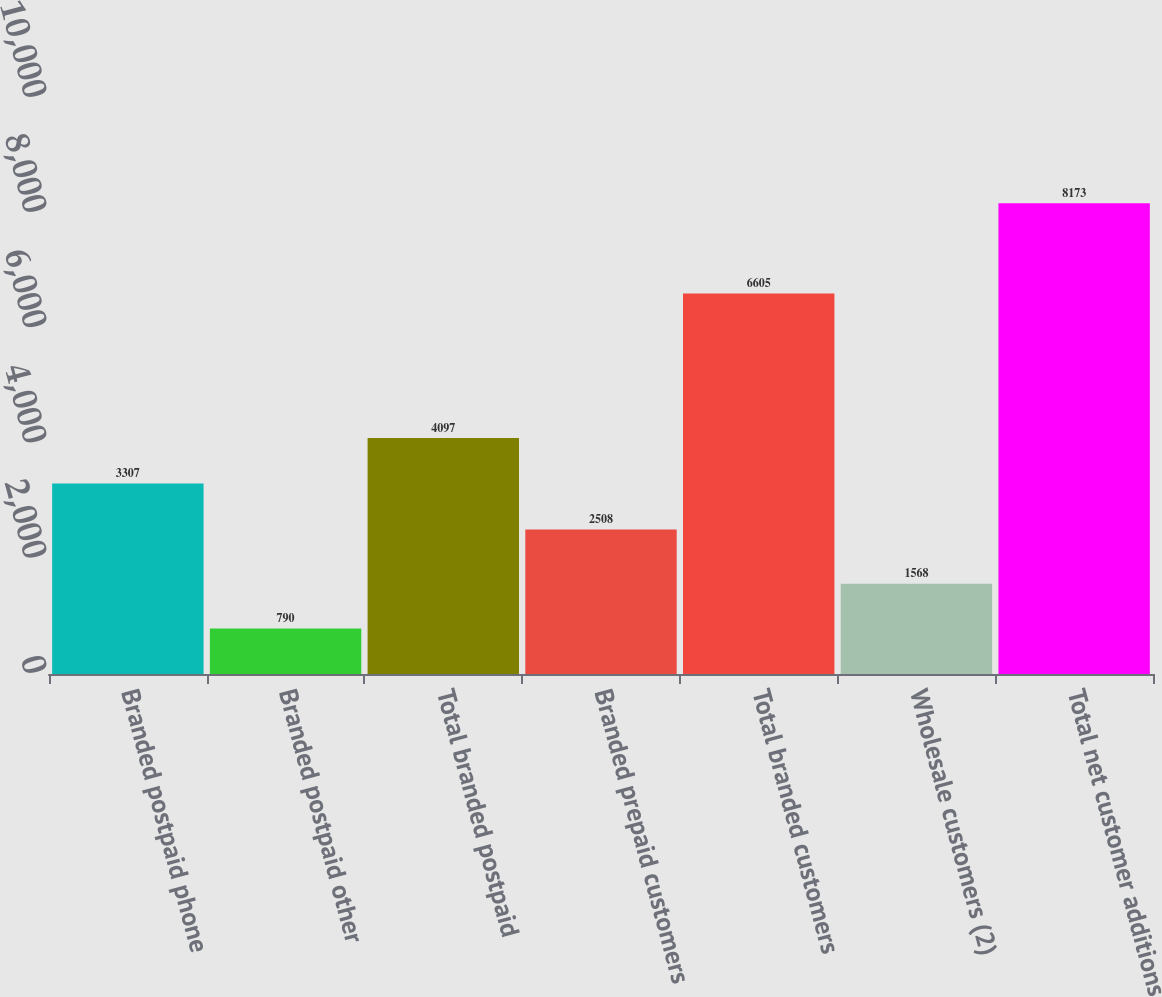<chart> <loc_0><loc_0><loc_500><loc_500><bar_chart><fcel>Branded postpaid phone<fcel>Branded postpaid other<fcel>Total branded postpaid<fcel>Branded prepaid customers<fcel>Total branded customers<fcel>Wholesale customers (2)<fcel>Total net customer additions<nl><fcel>3307<fcel>790<fcel>4097<fcel>2508<fcel>6605<fcel>1568<fcel>8173<nl></chart> 